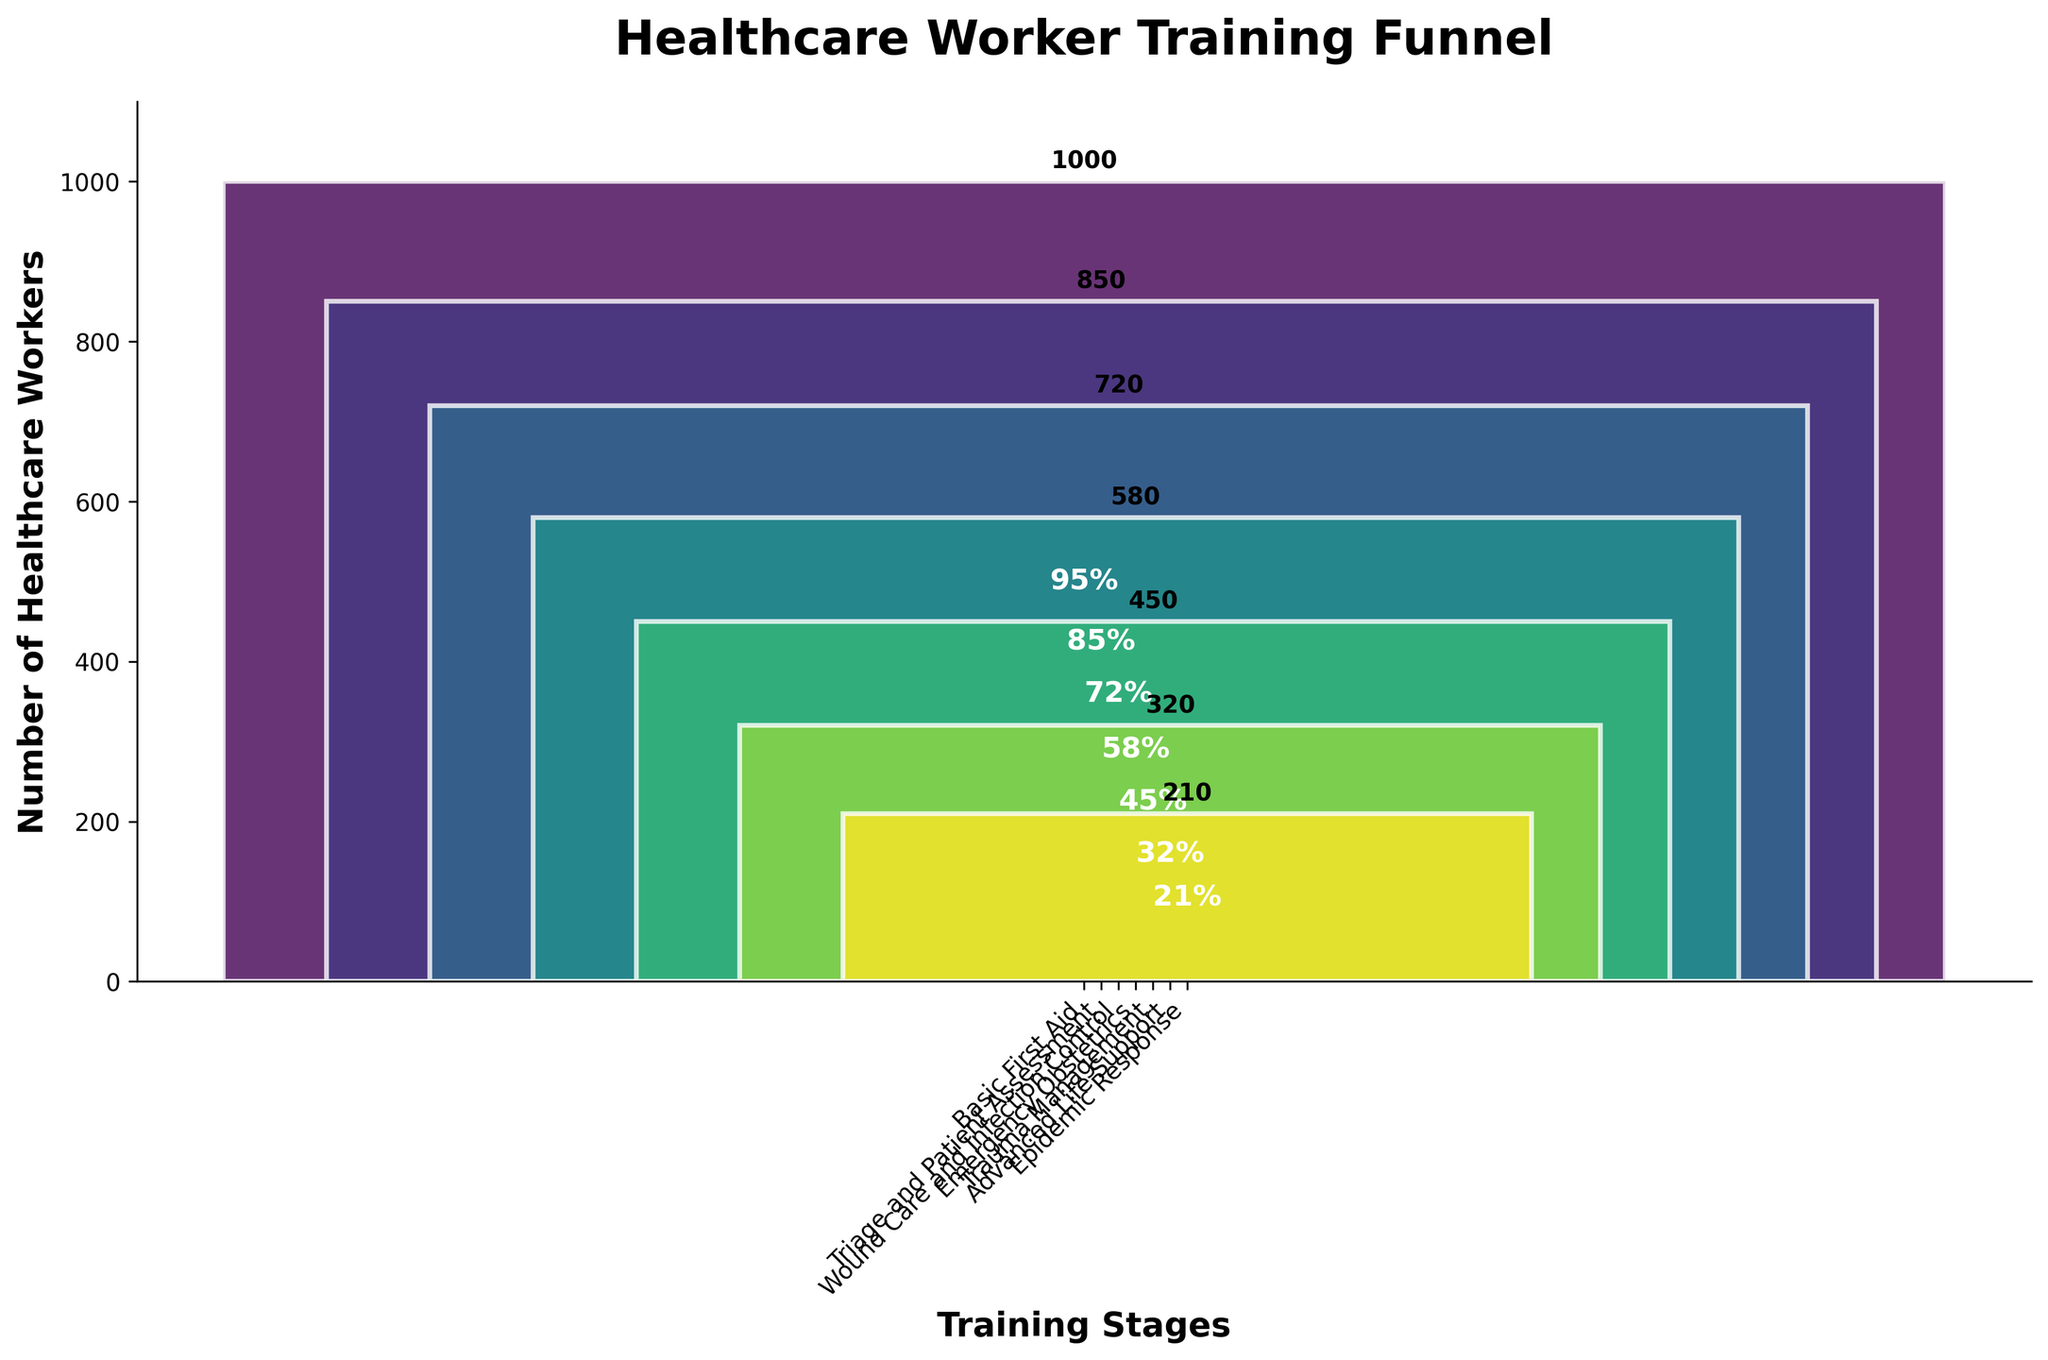How many healthcare workers completed the Basic First Aid training? The chart shows the number of healthcare workers for each stage. The bar for Basic First Aid clearly indicates 1000 workers.
Answer: 1000 What is the title of the chart? The title is typically displayed at the top of the chart. It reads "Healthcare Worker Training Funnel".
Answer: Healthcare Worker Training Funnel What is the completion rate for the Emergency Obstetrics training stage? The chart displays percentages inside the bars. For Emergency Obstetrics, the percentage shown is 58%.
Answer: 58% Which training stage has the lowest number of healthcare worker completions? By comparing the bars, the shortest bar corresponds to Epidemic Response, with the smallest number of workers.
Answer: Epidemic Response What is the difference in the number of healthcare workers between Trauma Management and Triage and Patient Assessment? The number of workers in Trauma Management is 450, and for Triage and Patient Assessment, it's 850. The difference is 850 - 450 = 400.
Answer: 400 How many healthcare workers completed both Basic First Aid and Advanced Life Support? The number of workers who completed Basic First Aid is 1000, and for Advanced Life Support, it is 320. Adding them gives 1000 + 320 = 1320.
Answer: 1320 Which training stage shows a 72% completion rate? The bar for Wound Care and Infection Control has the label "72%" on it.
Answer: Wound Care and Infection Control In terms of completion rates, which training stages have a rate of over 50%? The bars for Basic First Aid (95%), Triage and Patient Assessment (85%), and Wound Care and Infection Control (72%) show rates over 50%.
Answer: Basic First Aid, Triage and Patient Assessment, Wound Care and Infection Control What is the average completion rate across all training stages? The completion rates are 95%, 85%, 72%, 58%, 45%, 32%, and 21%. Summing these gives 408%, and there are 7 stages, so the average is 408/7 = 58.3%.
Answer: 58.3% How many more workers completed Triage and Patient Assessment compared to Advanced Life Support? Triage and Patient Assessment has 850 workers, and Advanced Life Support has 320 workers. The difference is 850 - 320 = 530.
Answer: 530 